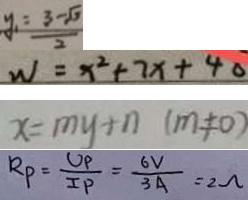<formula> <loc_0><loc_0><loc_500><loc_500>y _ { 1 } = \frac { 3 - \sqrt { 3 } } { 2 } 
 W = x ^ { 2 } + 7 x + 4 0 
 x = m y + n ( m \neq 0 ) 
 R _ { P } = \frac { U _ { P } } { I P } = \frac { 6 V } { 3 A } = 2 \Omega</formula> 